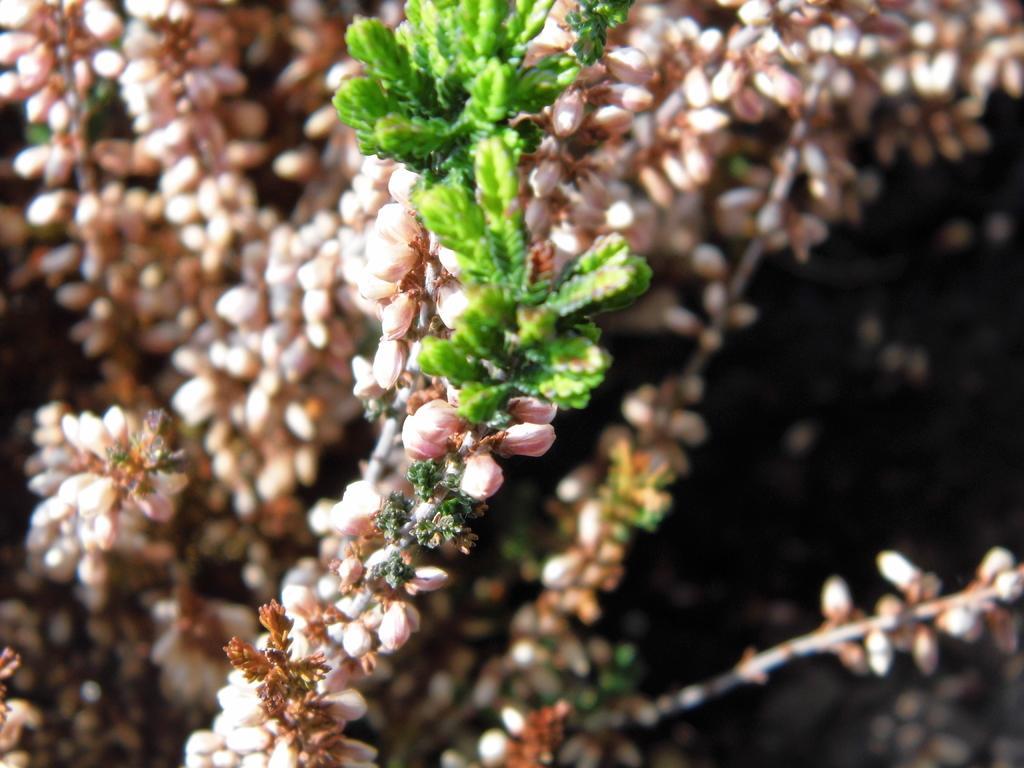Describe this image in one or two sentences. In this picture we can see plants and flower. 